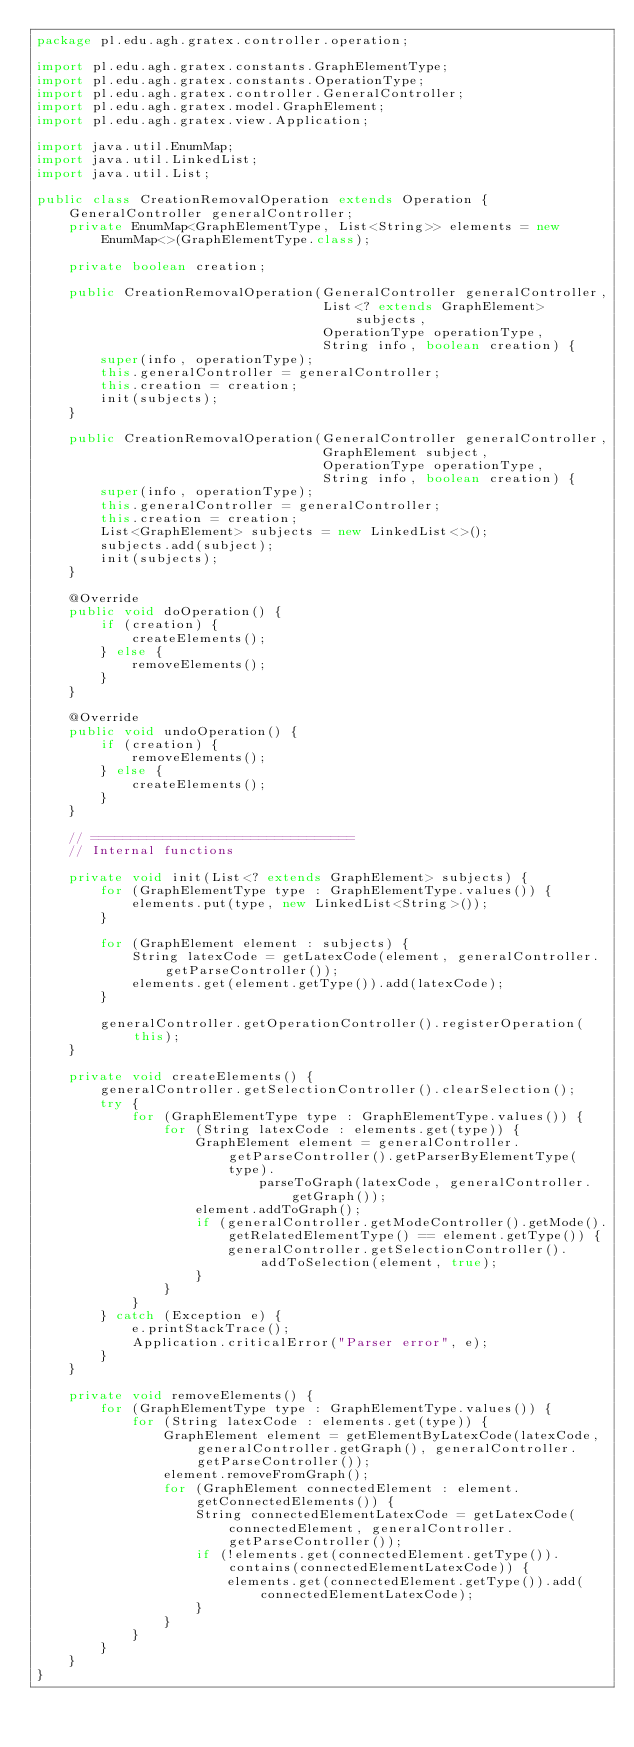<code> <loc_0><loc_0><loc_500><loc_500><_Java_>package pl.edu.agh.gratex.controller.operation;

import pl.edu.agh.gratex.constants.GraphElementType;
import pl.edu.agh.gratex.constants.OperationType;
import pl.edu.agh.gratex.controller.GeneralController;
import pl.edu.agh.gratex.model.GraphElement;
import pl.edu.agh.gratex.view.Application;

import java.util.EnumMap;
import java.util.LinkedList;
import java.util.List;

public class CreationRemovalOperation extends Operation {
    GeneralController generalController;
    private EnumMap<GraphElementType, List<String>> elements = new EnumMap<>(GraphElementType.class);

    private boolean creation;

    public CreationRemovalOperation(GeneralController generalController,
                                    List<? extends GraphElement> subjects,
                                    OperationType operationType,
                                    String info, boolean creation) {
        super(info, operationType);
        this.generalController = generalController;
        this.creation = creation;
        init(subjects);
    }

    public CreationRemovalOperation(GeneralController generalController,
                                    GraphElement subject,
                                    OperationType operationType,
                                    String info, boolean creation) {
        super(info, operationType);
        this.generalController = generalController;
        this.creation = creation;
        List<GraphElement> subjects = new LinkedList<>();
        subjects.add(subject);
        init(subjects);
    }

    @Override
    public void doOperation() {
        if (creation) {
            createElements();
        } else {
            removeElements();
        }
    }

    @Override
    public void undoOperation() {
        if (creation) {
            removeElements();
        } else {
            createElements();
        }
    }

    // =================================
    // Internal functions

    private void init(List<? extends GraphElement> subjects) {
        for (GraphElementType type : GraphElementType.values()) {
            elements.put(type, new LinkedList<String>());
        }

        for (GraphElement element : subjects) {
            String latexCode = getLatexCode(element, generalController.getParseController());
            elements.get(element.getType()).add(latexCode);
        }

        generalController.getOperationController().registerOperation(this);
    }

    private void createElements() {
        generalController.getSelectionController().clearSelection();
        try {
            for (GraphElementType type : GraphElementType.values()) {
                for (String latexCode : elements.get(type)) {
                    GraphElement element = generalController.getParseController().getParserByElementType(type).
                            parseToGraph(latexCode, generalController.getGraph());
                    element.addToGraph();
                    if (generalController.getModeController().getMode().getRelatedElementType() == element.getType()) {
                        generalController.getSelectionController().addToSelection(element, true);
                    }
                }
            }
        } catch (Exception e) {
            e.printStackTrace();
            Application.criticalError("Parser error", e);
        }
    }

    private void removeElements() {
        for (GraphElementType type : GraphElementType.values()) {
            for (String latexCode : elements.get(type)) {
                GraphElement element = getElementByLatexCode(latexCode, generalController.getGraph(), generalController.getParseController());
                element.removeFromGraph();
                for (GraphElement connectedElement : element.getConnectedElements()) {
                    String connectedElementLatexCode = getLatexCode(connectedElement, generalController.getParseController());
                    if (!elements.get(connectedElement.getType()).contains(connectedElementLatexCode)) {
                        elements.get(connectedElement.getType()).add(connectedElementLatexCode);
                    }
                }
            }
        }
    }
}
</code> 